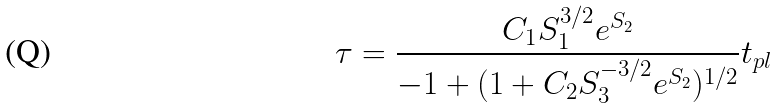<formula> <loc_0><loc_0><loc_500><loc_500>\tau = \frac { C _ { 1 } S _ { 1 } ^ { 3 / 2 } e ^ { S _ { 2 } } } { - 1 + ( 1 + C _ { 2 } S _ { 3 } ^ { - 3 / 2 } e ^ { S _ { 2 } } ) ^ { 1 / 2 } } t _ { p l }</formula> 